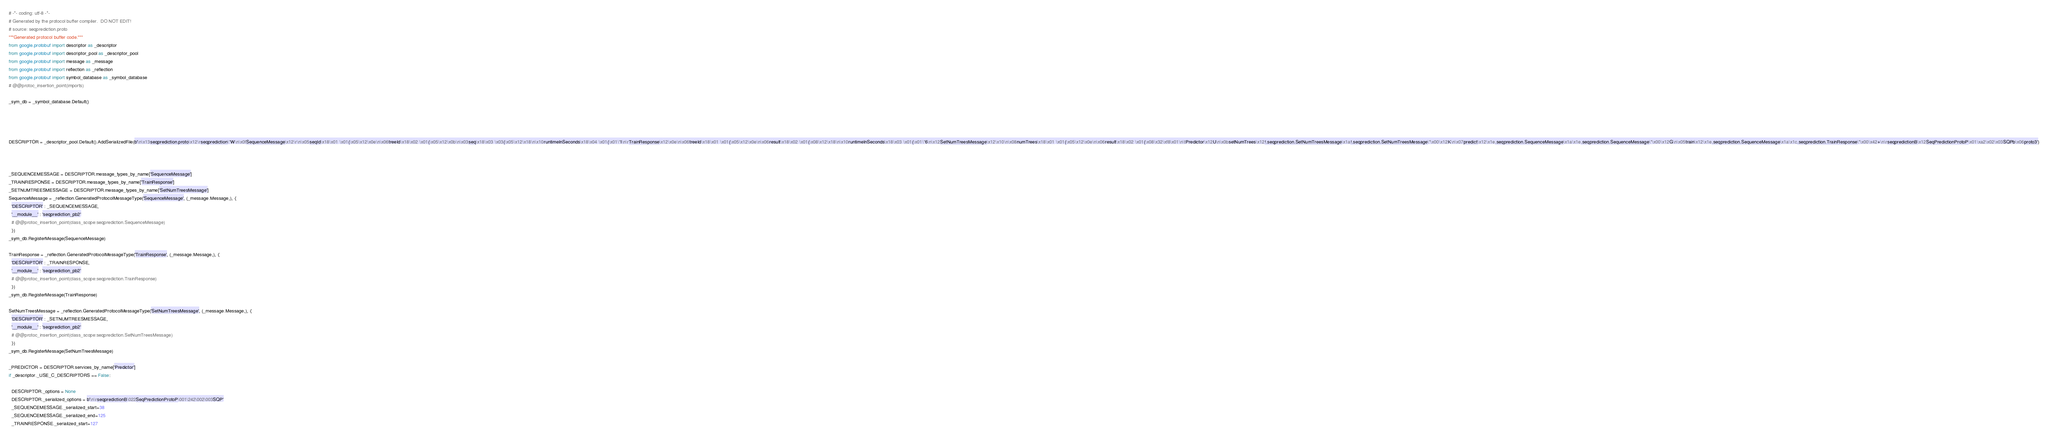<code> <loc_0><loc_0><loc_500><loc_500><_Python_># -*- coding: utf-8 -*-
# Generated by the protocol buffer compiler.  DO NOT EDIT!
# source: seqprediction.proto
"""Generated protocol buffer code."""
from google.protobuf import descriptor as _descriptor
from google.protobuf import descriptor_pool as _descriptor_pool
from google.protobuf import message as _message
from google.protobuf import reflection as _reflection
from google.protobuf import symbol_database as _symbol_database
# @@protoc_insertion_point(imports)

_sym_db = _symbol_database.Default()




DESCRIPTOR = _descriptor_pool.Default().AddSerializedFile(b'\n\x13seqprediction.proto\x12\rseqprediction\"W\n\x0fSequenceMessage\x12\r\n\x05seqId\x18\x01 \x01(\x05\x12\x0e\n\x06treeId\x18\x02 \x01(\x05\x12\x0b\n\x03seq\x18\x03 \x03(\x05\x12\x18\n\x10runtimeInSeconds\x18\x04 \x01(\x01\"I\n\rTrainResponse\x12\x0e\n\x06treeId\x18\x01 \x01(\x05\x12\x0e\n\x06result\x18\x02 \x01(\x08\x12\x18\n\x10runtimeInSeconds\x18\x03 \x01(\x01\"6\n\x12SetNumTreesMessage\x12\x10\n\x08numTrees\x18\x01 \x01(\x05\x12\x0e\n\x06result\x18\x02 \x01(\x08\x32\xf8\x01\n\tPredictor\x12U\n\x0bsetNumTrees\x12!.seqprediction.SetNumTreesMessage\x1a!.seqprediction.SetNumTreesMessage\"\x00\x12K\n\x07predict\x12\x1e.seqprediction.SequenceMessage\x1a\x1e.seqprediction.SequenceMessage\"\x00\x12G\n\x05train\x12\x1e.seqprediction.SequenceMessage\x1a\x1c.seqprediction.TrainResponse\"\x00\x42+\n\rseqpredictionB\x12SeqPredictionProtoP\x01\xa2\x02\x03SQPb\x06proto3')



_SEQUENCEMESSAGE = DESCRIPTOR.message_types_by_name['SequenceMessage']
_TRAINRESPONSE = DESCRIPTOR.message_types_by_name['TrainResponse']
_SETNUMTREESMESSAGE = DESCRIPTOR.message_types_by_name['SetNumTreesMessage']
SequenceMessage = _reflection.GeneratedProtocolMessageType('SequenceMessage', (_message.Message,), {
  'DESCRIPTOR' : _SEQUENCEMESSAGE,
  '__module__' : 'seqprediction_pb2'
  # @@protoc_insertion_point(class_scope:seqprediction.SequenceMessage)
  })
_sym_db.RegisterMessage(SequenceMessage)

TrainResponse = _reflection.GeneratedProtocolMessageType('TrainResponse', (_message.Message,), {
  'DESCRIPTOR' : _TRAINRESPONSE,
  '__module__' : 'seqprediction_pb2'
  # @@protoc_insertion_point(class_scope:seqprediction.TrainResponse)
  })
_sym_db.RegisterMessage(TrainResponse)

SetNumTreesMessage = _reflection.GeneratedProtocolMessageType('SetNumTreesMessage', (_message.Message,), {
  'DESCRIPTOR' : _SETNUMTREESMESSAGE,
  '__module__' : 'seqprediction_pb2'
  # @@protoc_insertion_point(class_scope:seqprediction.SetNumTreesMessage)
  })
_sym_db.RegisterMessage(SetNumTreesMessage)

_PREDICTOR = DESCRIPTOR.services_by_name['Predictor']
if _descriptor._USE_C_DESCRIPTORS == False:

  DESCRIPTOR._options = None
  DESCRIPTOR._serialized_options = b'\n\rseqpredictionB\022SeqPredictionProtoP\001\242\002\003SQP'
  _SEQUENCEMESSAGE._serialized_start=38
  _SEQUENCEMESSAGE._serialized_end=125
  _TRAINRESPONSE._serialized_start=127</code> 